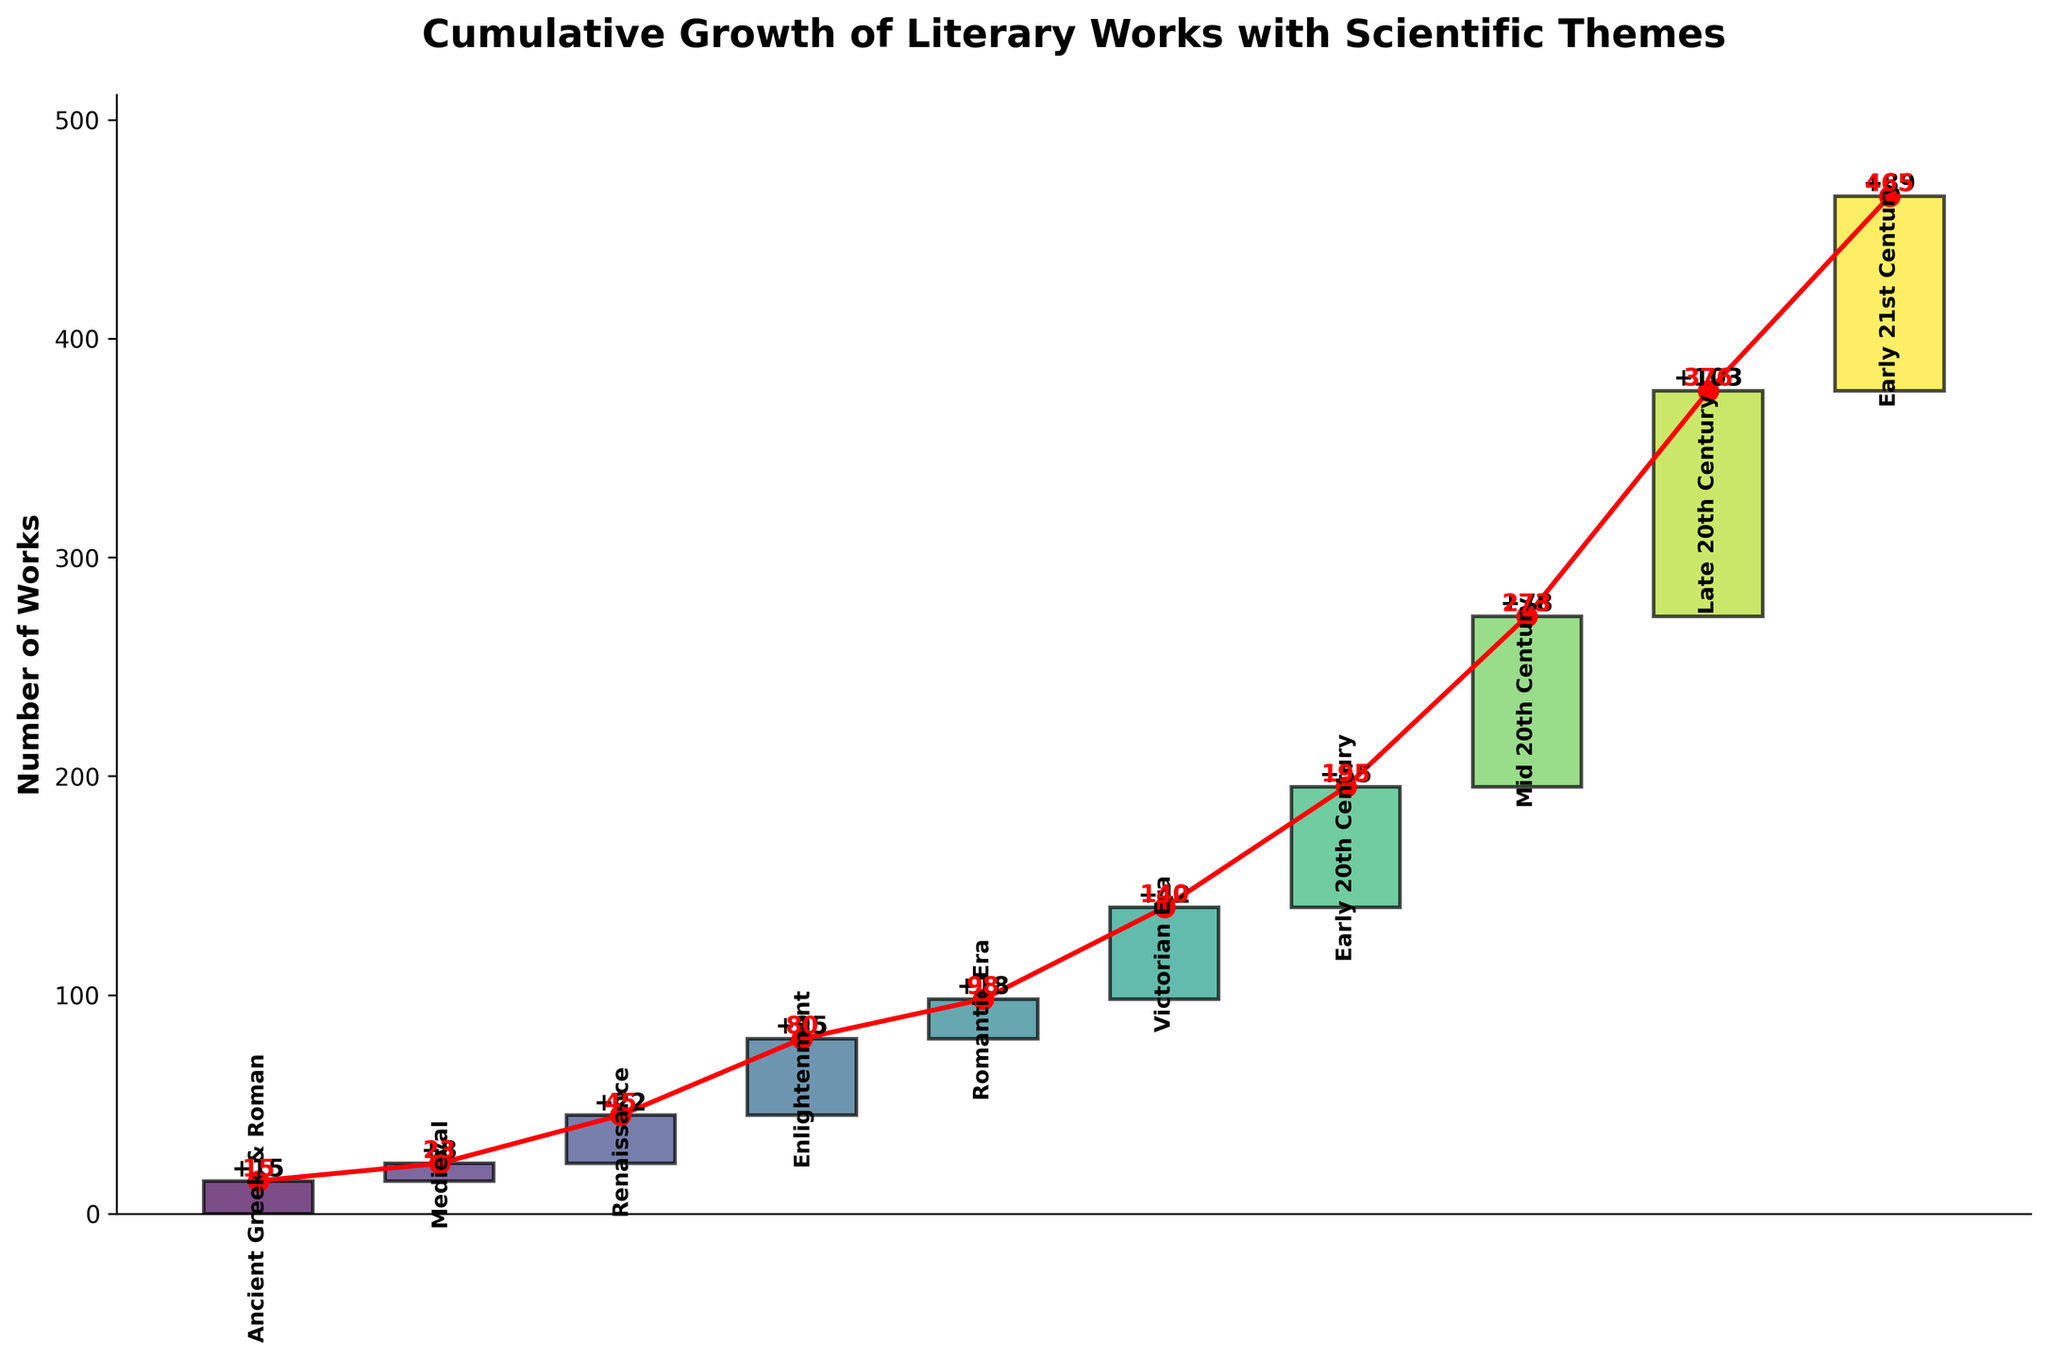What is the title of the chart? The title is displayed at the top of the chart. It provides an overview of what the chart represents.
Answer: Cumulative Growth of Literary Works with Scientific Themes How many periods are shown in the chart? Count the number of distinct periods labeled on the X-axis.
Answer: 10 Which period has the highest number of works added? Identify the bar segment with the greatest height. The label at the top of this segment shows the added number of works.
Answer: Late 20th Century What is the cumulative number of works by the end of the Renaissance period? The red marker connected by lines represents cumulative values. Identify the cumulative value corresponding to the Renaissance period.
Answer: 45 What is the difference in the number of works between the Enlightenment and Romantic Era? Find the values for the Enlightenment and Romantic Era and subtract the latter from the former (35 - 18).
Answer: 17 Which period saw the smallest number of literary works featuring scientific themes? Identify the shortest bar on the chart. The top label of this bar indicates the number of works.
Answer: Medieval What is the cumulative growth by the Victorian Era? Locate the red cumulative value label above the Victorian Era bar segment.
Answer: 140 What is the average number of works added per period? Sum the number of works added in each period and divide by the total number of periods ((15 + 8 + 22 + 35 + 18 + 42 + 55 + 78 + 103 + 89) / 10).
Answer: 46.5 Between which two periods did the cumulative number of works increase the most? Look at the steepest section of the red line connecting the cumulative values. Identify the corresponding periods at the steepest incline.
Answer: Mid 20th Century to Late 20th Century How does the Early 21st Century compare to the Late 20th Century in terms of cumulative literary works? Compare the cumulative values given at the top labels of these two periods (376 and 465), and state whether Early 21st Century has more or fewer works than the Late 20th Century.
Answer: More 